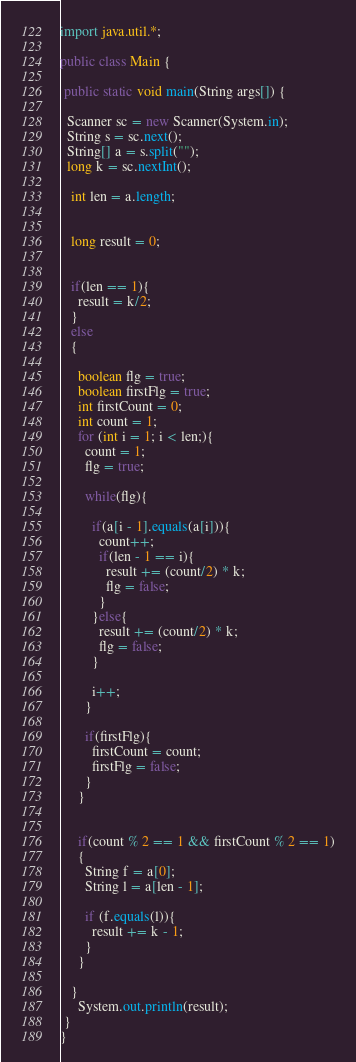<code> <loc_0><loc_0><loc_500><loc_500><_Java_>import java.util.*;

public class Main {

 public static void main(String args[]) {

  Scanner sc = new Scanner(System.in);
  String s = sc.next();
  String[] a = s.split("");
  long k = sc.nextInt();
   
   int len = a.length;

   
   long result = 0;

   
   if(len == 1){
     result = k/2;
   }
   else
   {
     
     boolean flg = true;
     boolean firstFlg = true;
     int firstCount = 0;
     int count = 1;
     for (int i = 1; i < len;){
       count = 1;
       flg = true;
         
       while(flg){
       
         if(a[i - 1].equals(a[i])){
           count++;
           if(len - 1 == i){
             result += (count/2) * k;
             flg = false;
           }
         }else{
           result += (count/2) * k;
           flg = false;
         }
         
         i++;
       } 
       
       if(firstFlg){
         firstCount = count;
         firstFlg = false;
       }
     }
     
       
     if(count % 2 == 1 && firstCount % 2 == 1)
     {  
       String f = a[0];
       String l = a[len - 1];
     
       if (f.equals(l)){
         result += k - 1;
       }
     }
     
   }
     System.out.println(result);
 }
}</code> 